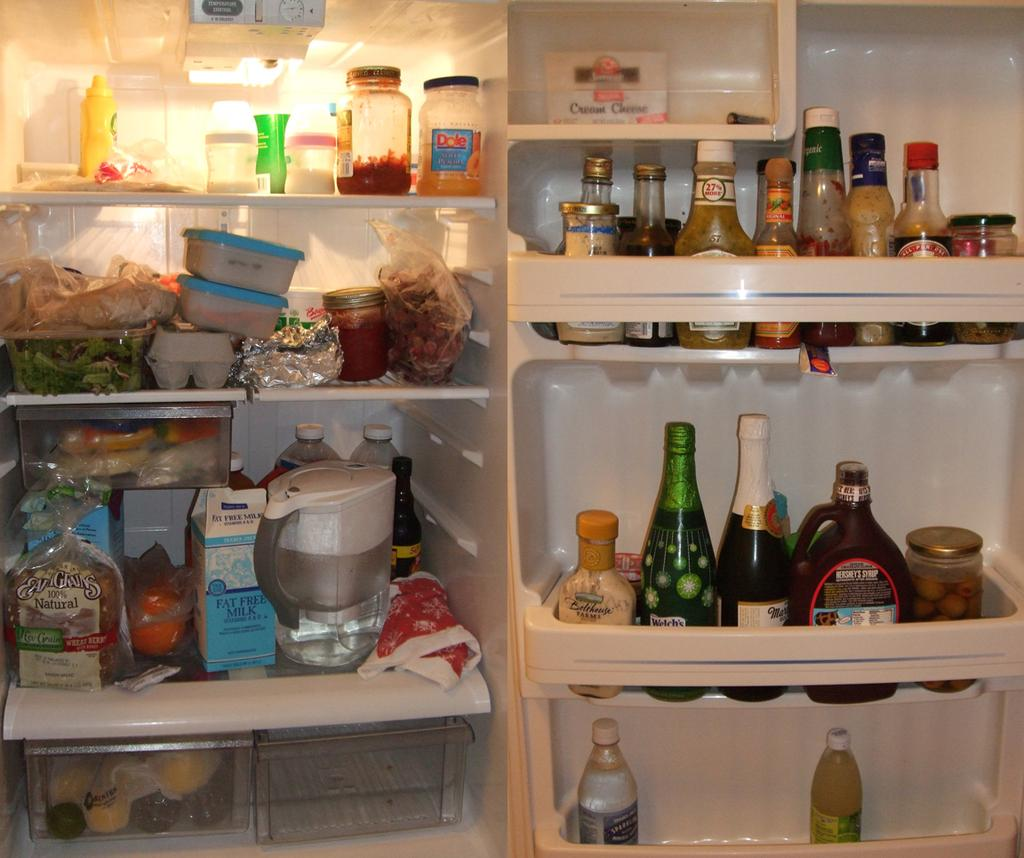Provide a one-sentence caption for the provided image. the inside of someone's refrigerator with Hershey's chocolate sauce on one shelf. 